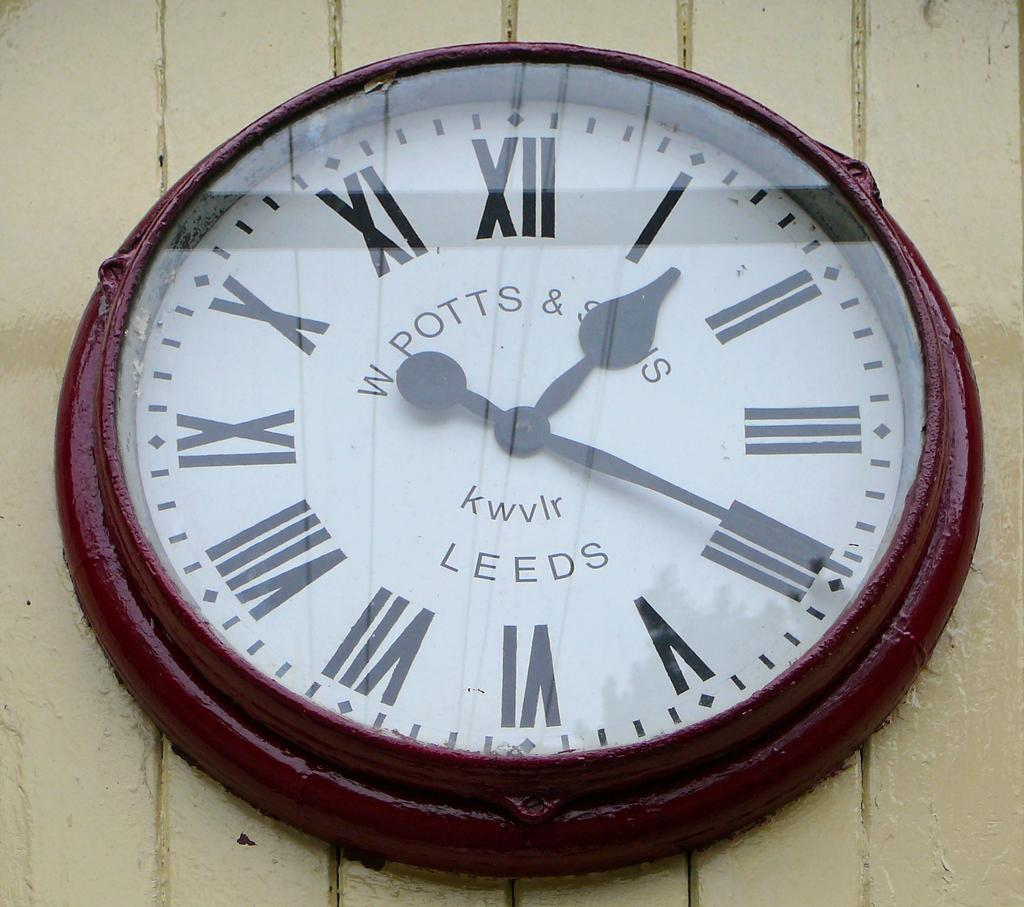<image>
Provide a brief description of the given image. A maroon colored framed clock with the word leeds on the bottom of the face. 